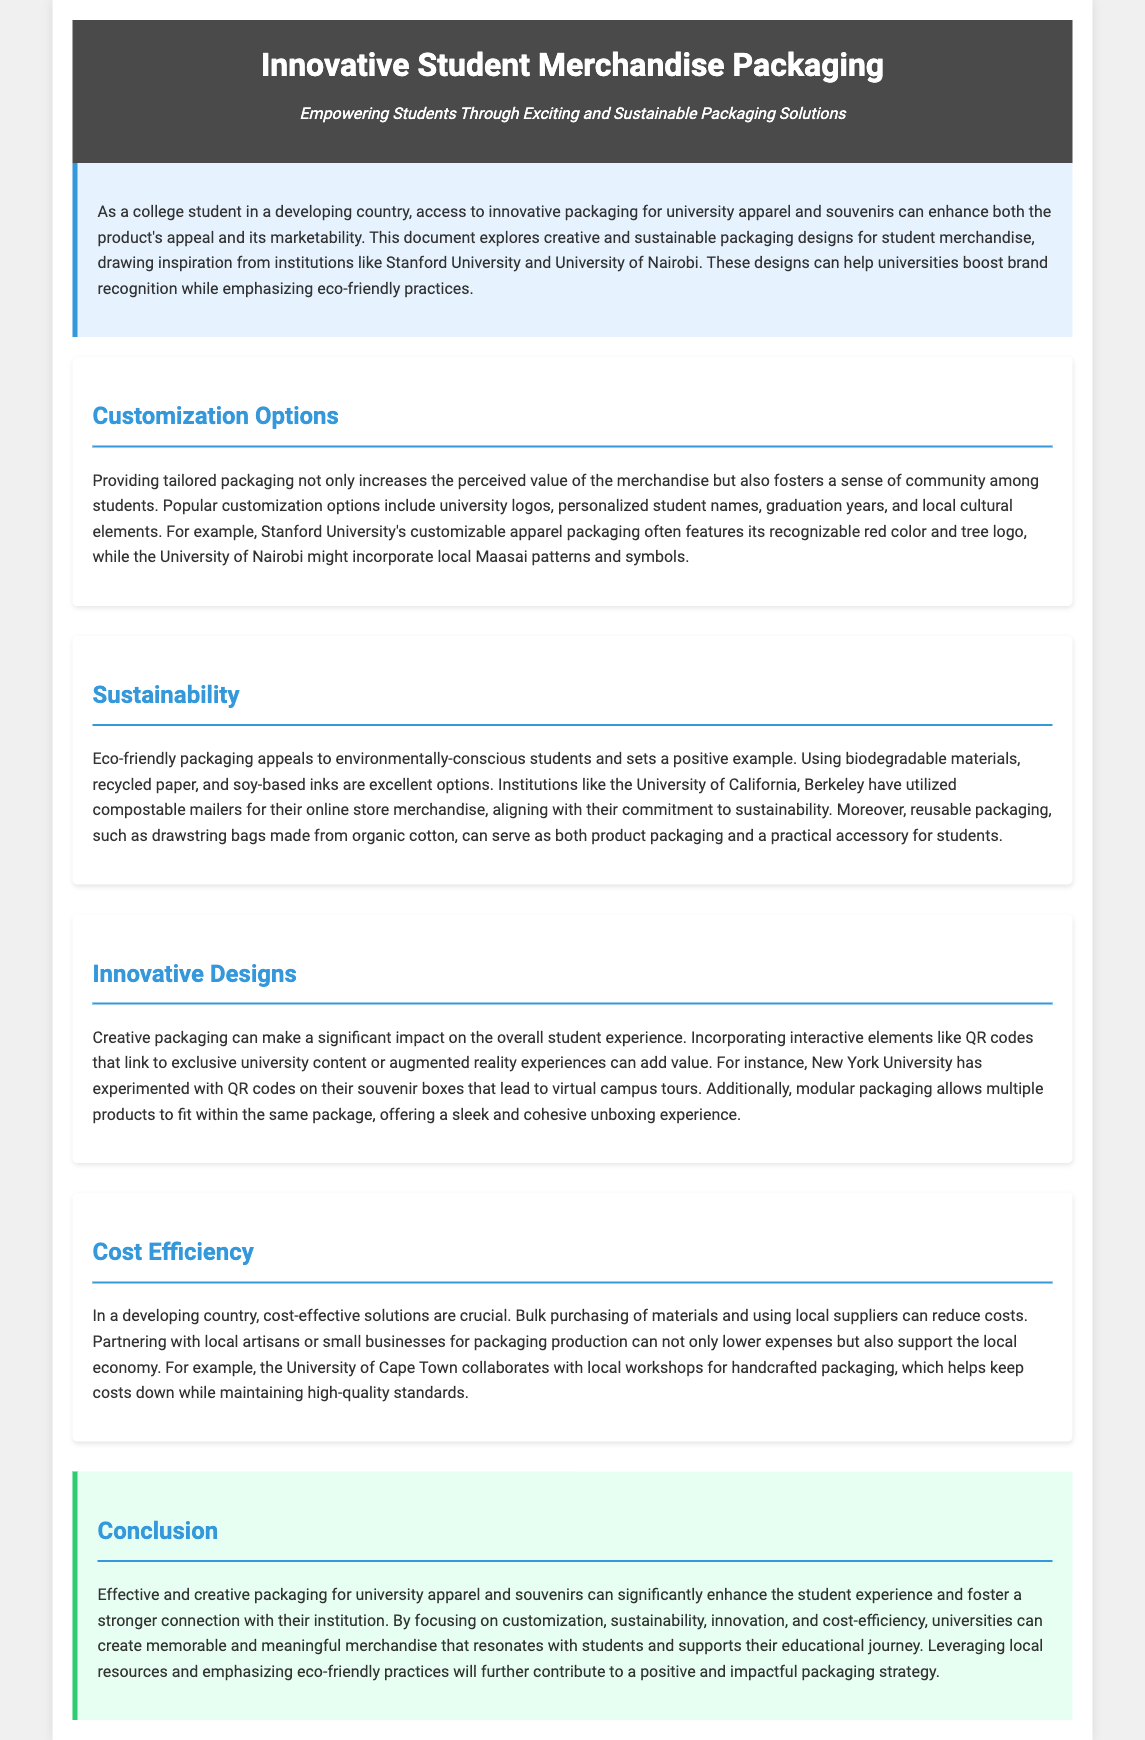what is the main focus of the document? The document focuses on innovative packaging solutions for student merchandise, emphasizing customization, sustainability, and cost-efficiency.
Answer: innovative packaging solutions for student merchandise which university is mentioned as an example for customization options? The document provides Stanford University as an example of customization in packaging design.
Answer: Stanford University what material is suggested for eco-friendly packaging? The document mentions biodegradable materials, recycled paper, and soy-based inks as suitable options for eco-friendly packaging.
Answer: biodegradable materials, recycled paper, and soy-based inks how can schools reduce packaging costs? The document states that bulk purchasing of materials and using local suppliers can help in reducing packaging costs.
Answer: bulk purchasing and using local suppliers what type of interactive element is proposed in innovative designs? The document suggests incorporating QR codes that link to exclusive university content as an interactive element in packaging.
Answer: QR codes what is one benefit of reusable packaging mentioned? The reusable packaging, such as drawstring bags, serves as both product packaging and a practical accessory for students.
Answer: practical accessory what is the ultimate goal of effective packaging for university souvenirs? The document states that the goal is to enhance the student experience and foster a stronger connection with their institution.
Answer: enhance the student experience which university used compostable mailers according to the document? The document mentions the University of California, Berkeley as an institution that has utilized compostable mailers.
Answer: University of California, Berkeley what does the conclusion emphasize about packaging strategy? The conclusion emphasizes leveraging local resources and emphasizing eco-friendly practices as important for a positive packaging strategy.
Answer: leveraging local resources and eco-friendly practices 